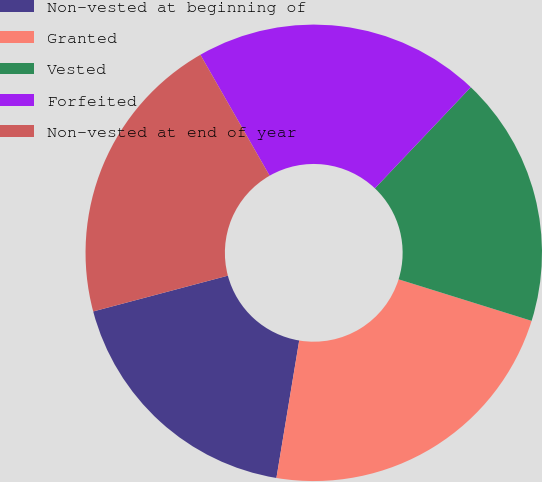Convert chart to OTSL. <chart><loc_0><loc_0><loc_500><loc_500><pie_chart><fcel>Non-vested at beginning of<fcel>Granted<fcel>Vested<fcel>Forfeited<fcel>Non-vested at end of year<nl><fcel>18.25%<fcel>22.8%<fcel>17.74%<fcel>20.35%<fcel>20.86%<nl></chart> 